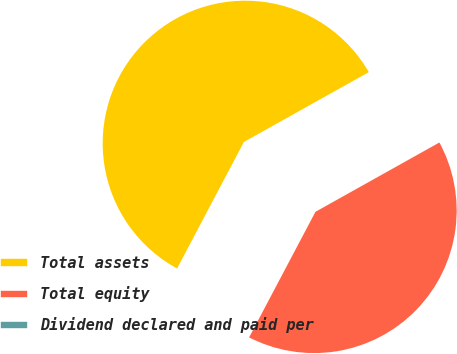Convert chart. <chart><loc_0><loc_0><loc_500><loc_500><pie_chart><fcel>Total assets<fcel>Total equity<fcel>Dividend declared and paid per<nl><fcel>59.15%<fcel>40.85%<fcel>0.0%<nl></chart> 